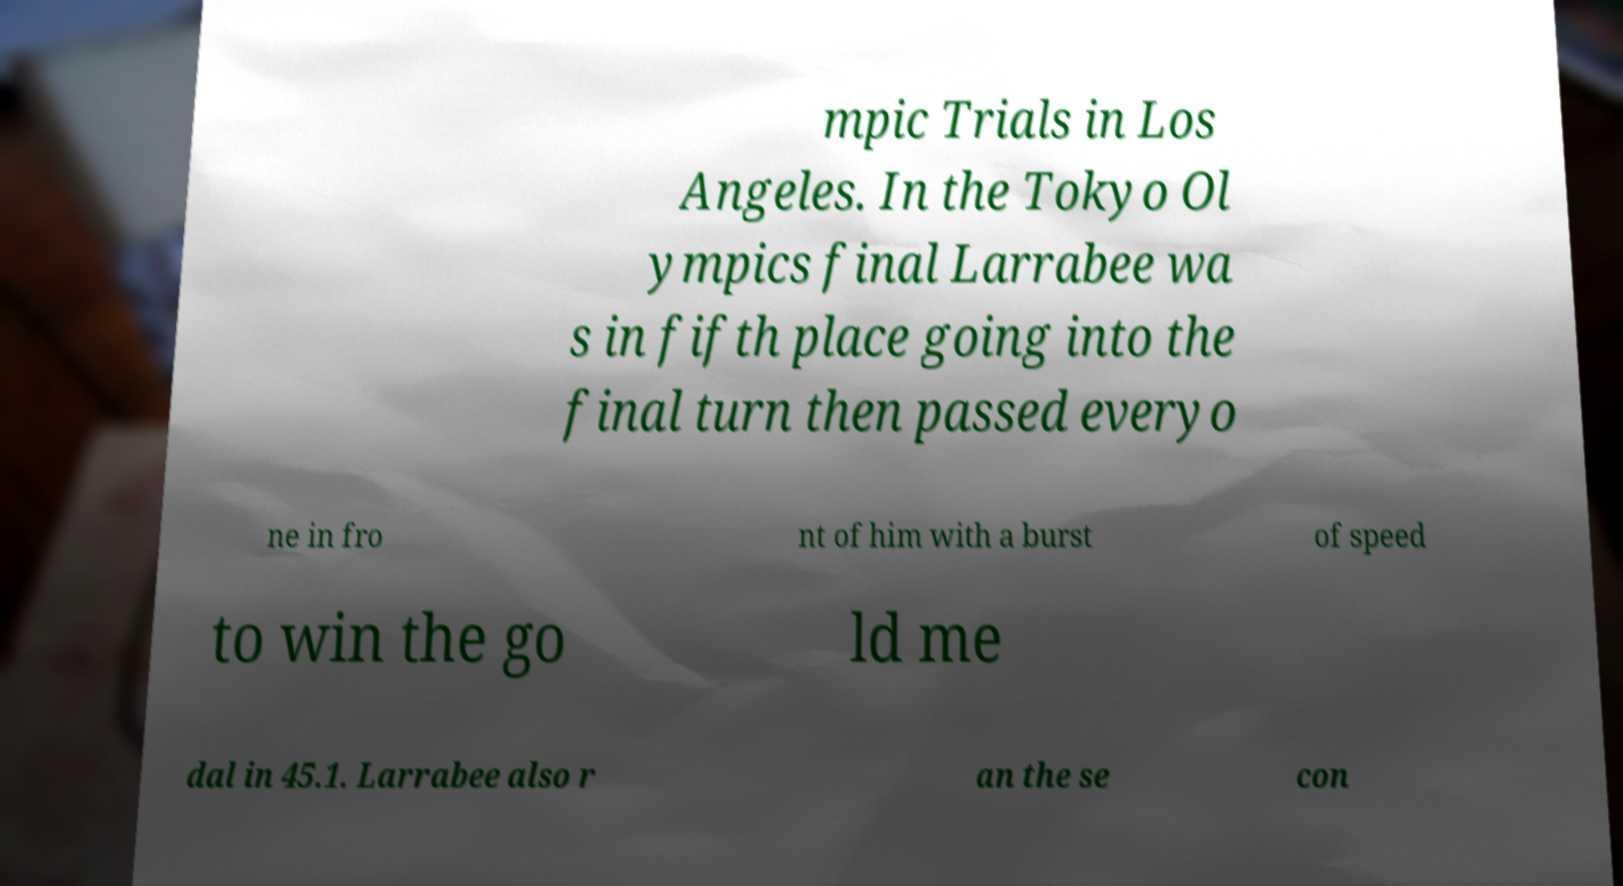I need the written content from this picture converted into text. Can you do that? mpic Trials in Los Angeles. In the Tokyo Ol ympics final Larrabee wa s in fifth place going into the final turn then passed everyo ne in fro nt of him with a burst of speed to win the go ld me dal in 45.1. Larrabee also r an the se con 